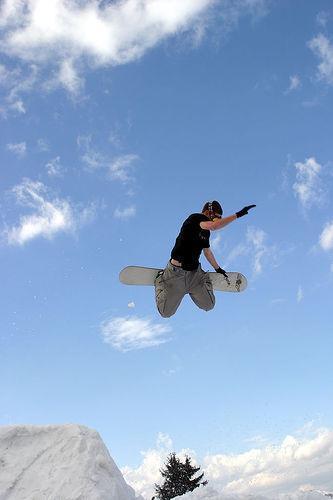How many different colors are in the sky?
Give a very brief answer. 2. How many hands are touching the snowboard?
Give a very brief answer. 1. How many snowboarders in the photo?
Give a very brief answer. 1. 